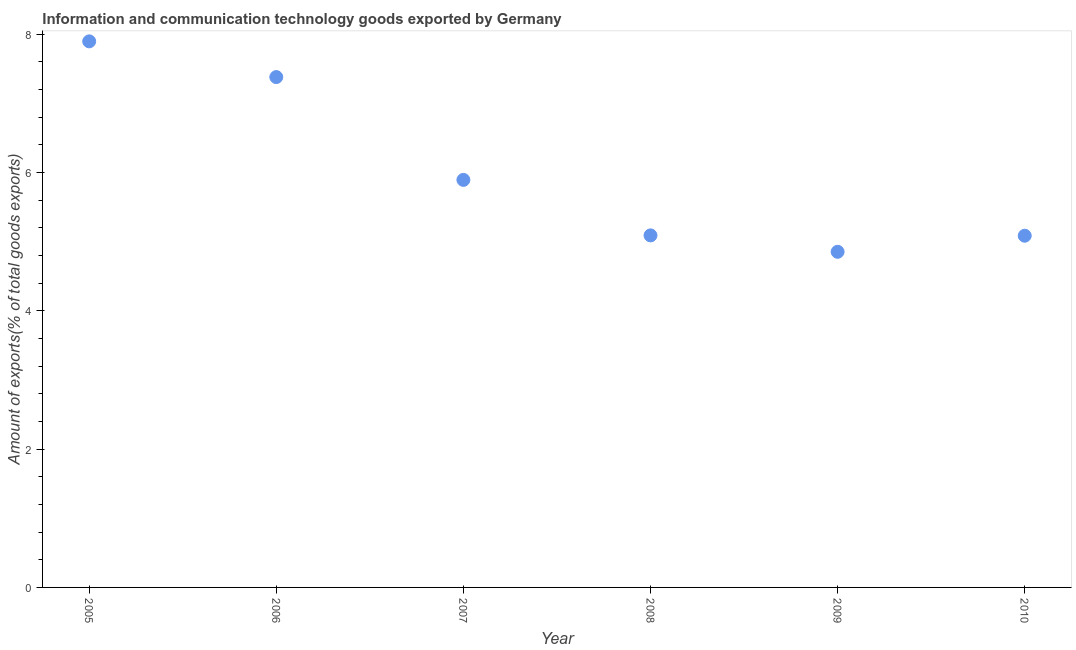What is the amount of ict goods exports in 2006?
Provide a short and direct response. 7.38. Across all years, what is the maximum amount of ict goods exports?
Your answer should be very brief. 7.9. Across all years, what is the minimum amount of ict goods exports?
Provide a succinct answer. 4.85. What is the sum of the amount of ict goods exports?
Offer a very short reply. 36.2. What is the difference between the amount of ict goods exports in 2007 and 2009?
Offer a very short reply. 1.04. What is the average amount of ict goods exports per year?
Offer a terse response. 6.03. What is the median amount of ict goods exports?
Offer a very short reply. 5.49. In how many years, is the amount of ict goods exports greater than 3.6 %?
Provide a short and direct response. 6. Do a majority of the years between 2007 and 2006 (inclusive) have amount of ict goods exports greater than 7.2 %?
Offer a very short reply. No. What is the ratio of the amount of ict goods exports in 2005 to that in 2010?
Offer a terse response. 1.55. Is the amount of ict goods exports in 2006 less than that in 2009?
Give a very brief answer. No. Is the difference between the amount of ict goods exports in 2006 and 2008 greater than the difference between any two years?
Your answer should be very brief. No. What is the difference between the highest and the second highest amount of ict goods exports?
Provide a succinct answer. 0.52. Is the sum of the amount of ict goods exports in 2008 and 2009 greater than the maximum amount of ict goods exports across all years?
Provide a short and direct response. Yes. What is the difference between the highest and the lowest amount of ict goods exports?
Your answer should be compact. 3.04. How many years are there in the graph?
Your response must be concise. 6. What is the difference between two consecutive major ticks on the Y-axis?
Your answer should be compact. 2. Does the graph contain any zero values?
Keep it short and to the point. No. Does the graph contain grids?
Provide a succinct answer. No. What is the title of the graph?
Ensure brevity in your answer.  Information and communication technology goods exported by Germany. What is the label or title of the X-axis?
Your response must be concise. Year. What is the label or title of the Y-axis?
Make the answer very short. Amount of exports(% of total goods exports). What is the Amount of exports(% of total goods exports) in 2005?
Provide a short and direct response. 7.9. What is the Amount of exports(% of total goods exports) in 2006?
Ensure brevity in your answer.  7.38. What is the Amount of exports(% of total goods exports) in 2007?
Provide a succinct answer. 5.89. What is the Amount of exports(% of total goods exports) in 2008?
Provide a short and direct response. 5.09. What is the Amount of exports(% of total goods exports) in 2009?
Your answer should be compact. 4.85. What is the Amount of exports(% of total goods exports) in 2010?
Make the answer very short. 5.09. What is the difference between the Amount of exports(% of total goods exports) in 2005 and 2006?
Give a very brief answer. 0.52. What is the difference between the Amount of exports(% of total goods exports) in 2005 and 2007?
Offer a very short reply. 2. What is the difference between the Amount of exports(% of total goods exports) in 2005 and 2008?
Provide a succinct answer. 2.81. What is the difference between the Amount of exports(% of total goods exports) in 2005 and 2009?
Make the answer very short. 3.04. What is the difference between the Amount of exports(% of total goods exports) in 2005 and 2010?
Your response must be concise. 2.81. What is the difference between the Amount of exports(% of total goods exports) in 2006 and 2007?
Your answer should be compact. 1.49. What is the difference between the Amount of exports(% of total goods exports) in 2006 and 2008?
Provide a short and direct response. 2.29. What is the difference between the Amount of exports(% of total goods exports) in 2006 and 2009?
Your answer should be compact. 2.53. What is the difference between the Amount of exports(% of total goods exports) in 2006 and 2010?
Keep it short and to the point. 2.29. What is the difference between the Amount of exports(% of total goods exports) in 2007 and 2008?
Make the answer very short. 0.8. What is the difference between the Amount of exports(% of total goods exports) in 2007 and 2009?
Your answer should be very brief. 1.04. What is the difference between the Amount of exports(% of total goods exports) in 2007 and 2010?
Your response must be concise. 0.81. What is the difference between the Amount of exports(% of total goods exports) in 2008 and 2009?
Your answer should be very brief. 0.24. What is the difference between the Amount of exports(% of total goods exports) in 2008 and 2010?
Provide a short and direct response. 0. What is the difference between the Amount of exports(% of total goods exports) in 2009 and 2010?
Your response must be concise. -0.23. What is the ratio of the Amount of exports(% of total goods exports) in 2005 to that in 2006?
Your response must be concise. 1.07. What is the ratio of the Amount of exports(% of total goods exports) in 2005 to that in 2007?
Your answer should be very brief. 1.34. What is the ratio of the Amount of exports(% of total goods exports) in 2005 to that in 2008?
Give a very brief answer. 1.55. What is the ratio of the Amount of exports(% of total goods exports) in 2005 to that in 2009?
Provide a short and direct response. 1.63. What is the ratio of the Amount of exports(% of total goods exports) in 2005 to that in 2010?
Offer a terse response. 1.55. What is the ratio of the Amount of exports(% of total goods exports) in 2006 to that in 2007?
Offer a very short reply. 1.25. What is the ratio of the Amount of exports(% of total goods exports) in 2006 to that in 2008?
Your answer should be very brief. 1.45. What is the ratio of the Amount of exports(% of total goods exports) in 2006 to that in 2009?
Provide a succinct answer. 1.52. What is the ratio of the Amount of exports(% of total goods exports) in 2006 to that in 2010?
Give a very brief answer. 1.45. What is the ratio of the Amount of exports(% of total goods exports) in 2007 to that in 2008?
Your answer should be compact. 1.16. What is the ratio of the Amount of exports(% of total goods exports) in 2007 to that in 2009?
Provide a succinct answer. 1.21. What is the ratio of the Amount of exports(% of total goods exports) in 2007 to that in 2010?
Your answer should be compact. 1.16. What is the ratio of the Amount of exports(% of total goods exports) in 2008 to that in 2009?
Your answer should be compact. 1.05. What is the ratio of the Amount of exports(% of total goods exports) in 2008 to that in 2010?
Provide a short and direct response. 1. What is the ratio of the Amount of exports(% of total goods exports) in 2009 to that in 2010?
Your answer should be compact. 0.95. 